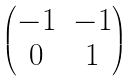Convert formula to latex. <formula><loc_0><loc_0><loc_500><loc_500>\begin{pmatrix} - 1 & - 1 \\ 0 & 1 \end{pmatrix}</formula> 